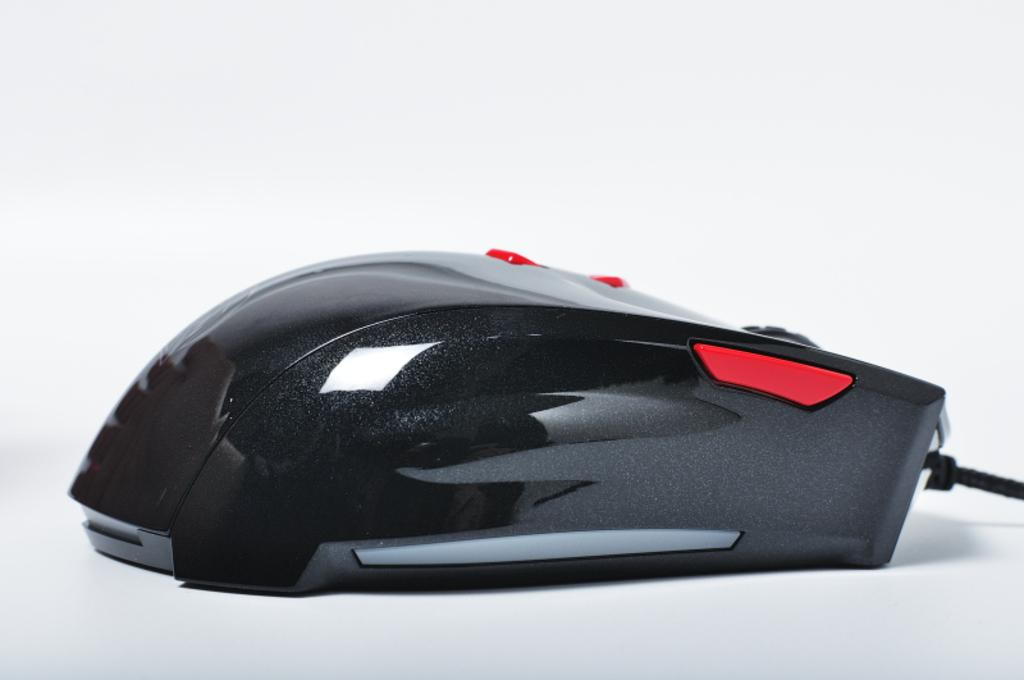What type of animal is present in the image? There is a mouse in the image. What color is the mouse? The mouse is black in color. How many horses can be seen in the image? There are no horses present in the image; it features a black mouse. What type of insect is shown interacting with the mouse in the image? There is no insect shown interacting with the mouse in the image. 